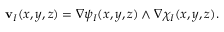Convert formula to latex. <formula><loc_0><loc_0><loc_500><loc_500>v _ { I } ( x , y , z ) = \nabla \psi _ { I } ( x , y , z ) \wedge \nabla \chi _ { I } ( x , y , z ) .</formula> 